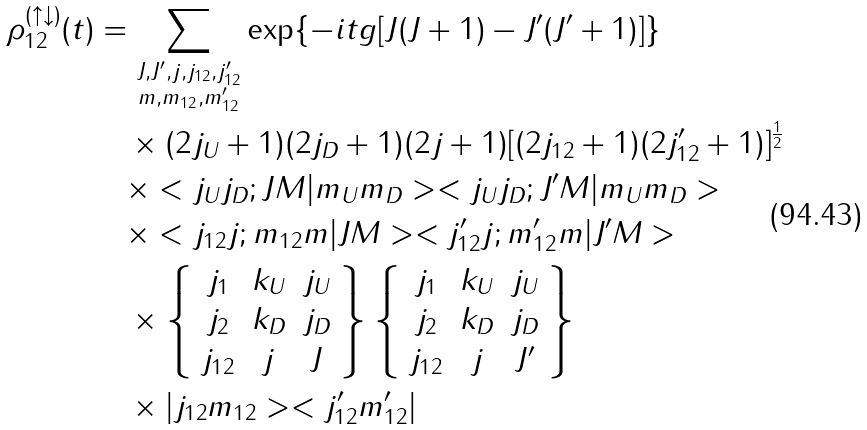<formula> <loc_0><loc_0><loc_500><loc_500>\rho _ { 1 2 } ^ { ( \uparrow \downarrow ) } ( t ) & = \sum _ { \substack { J , J ^ { \prime } , j , j _ { 1 2 } , j ^ { \prime } _ { 1 2 } \\ m , m _ { 1 2 } , m ^ { \prime } _ { 1 2 } } } \exp \{ - i t g [ J ( J + 1 ) - J ^ { \prime } ( J ^ { \prime } + 1 ) ] \} \\ & \quad \times ( 2 j _ { U } + 1 ) ( 2 j _ { D } + 1 ) ( 2 j + 1 ) [ ( 2 j _ { 1 2 } + 1 ) ( 2 j ^ { \prime } _ { 1 2 } + 1 ) ] ^ { \frac { 1 } { 2 } } \\ & \quad \times < j _ { U } j _ { D } ; J M | m _ { U } m _ { D } > < j _ { U } j _ { D } ; J ^ { \prime } M | m _ { U } m _ { D } > \\ & \quad \times < j _ { 1 2 } j ; m _ { 1 2 } m | J M > < j ^ { \prime } _ { 1 2 } j ; m ^ { \prime } _ { 1 2 } m | J ^ { \prime } M > \\ & \quad \times \left \{ \begin{array} { c c c } j _ { 1 } & k _ { U } & j _ { U } \\ j _ { 2 } & k _ { D } & j _ { D } \\ j _ { 1 2 } & j & J \\ \end{array} \right \} \left \{ \begin{array} { c c c } j _ { 1 } & k _ { U } & j _ { U } \\ j _ { 2 } & k _ { D } & j _ { D } \\ j _ { 1 2 } & j & J ^ { \prime } \\ \end{array} \right \} \\ & \quad \times | j _ { 1 2 } m _ { 1 2 } > < j ^ { \prime } _ { 1 2 } m ^ { \prime } _ { 1 2 } | \\</formula> 